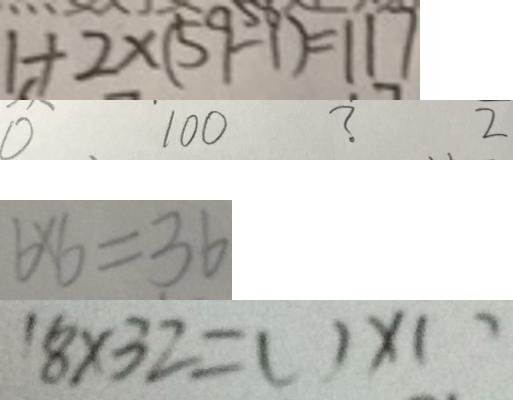Convert formula to latex. <formula><loc_0><loc_0><loc_500><loc_500>1 + 2 \times ( 5 9 - 1 ) = 1 1 7 
 0 1 0 0 ? 2 
 6 \times 6 = 3 6 
 1 8 \times 3 2 = ( ) \times ( )</formula> 